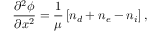<formula> <loc_0><loc_0><loc_500><loc_500>\frac { \partial ^ { 2 } \phi } { \partial x ^ { 2 } } = \frac { 1 } { \mu } \left [ n _ { d } + n _ { e } - n _ { i } \right ] ,</formula> 